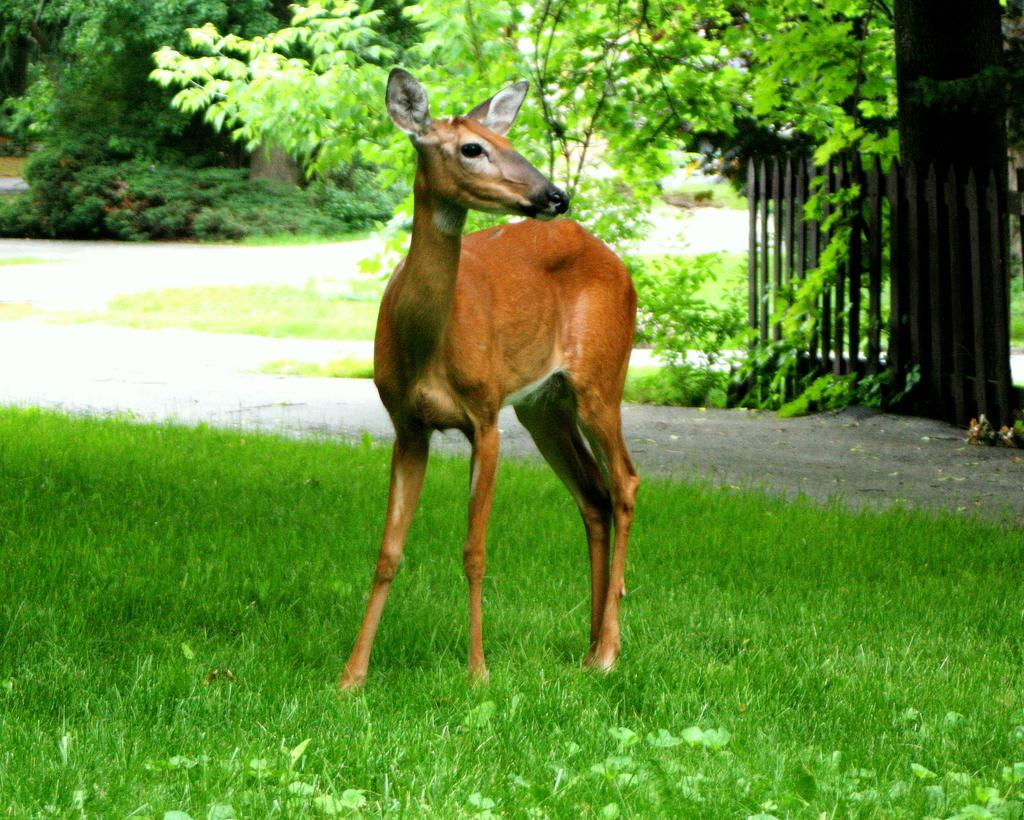What animal is in the center of the image? There is a deer in the center of the image. What can be seen on the right side of the image? There is a boundary on the right side of the image. What type of environment is depicted in the image? There is greenery around the area of the image, suggesting a natural setting. What type of comb is being used by the deer in the image? There is no comb present in the image, and the deer is not using any tool. 